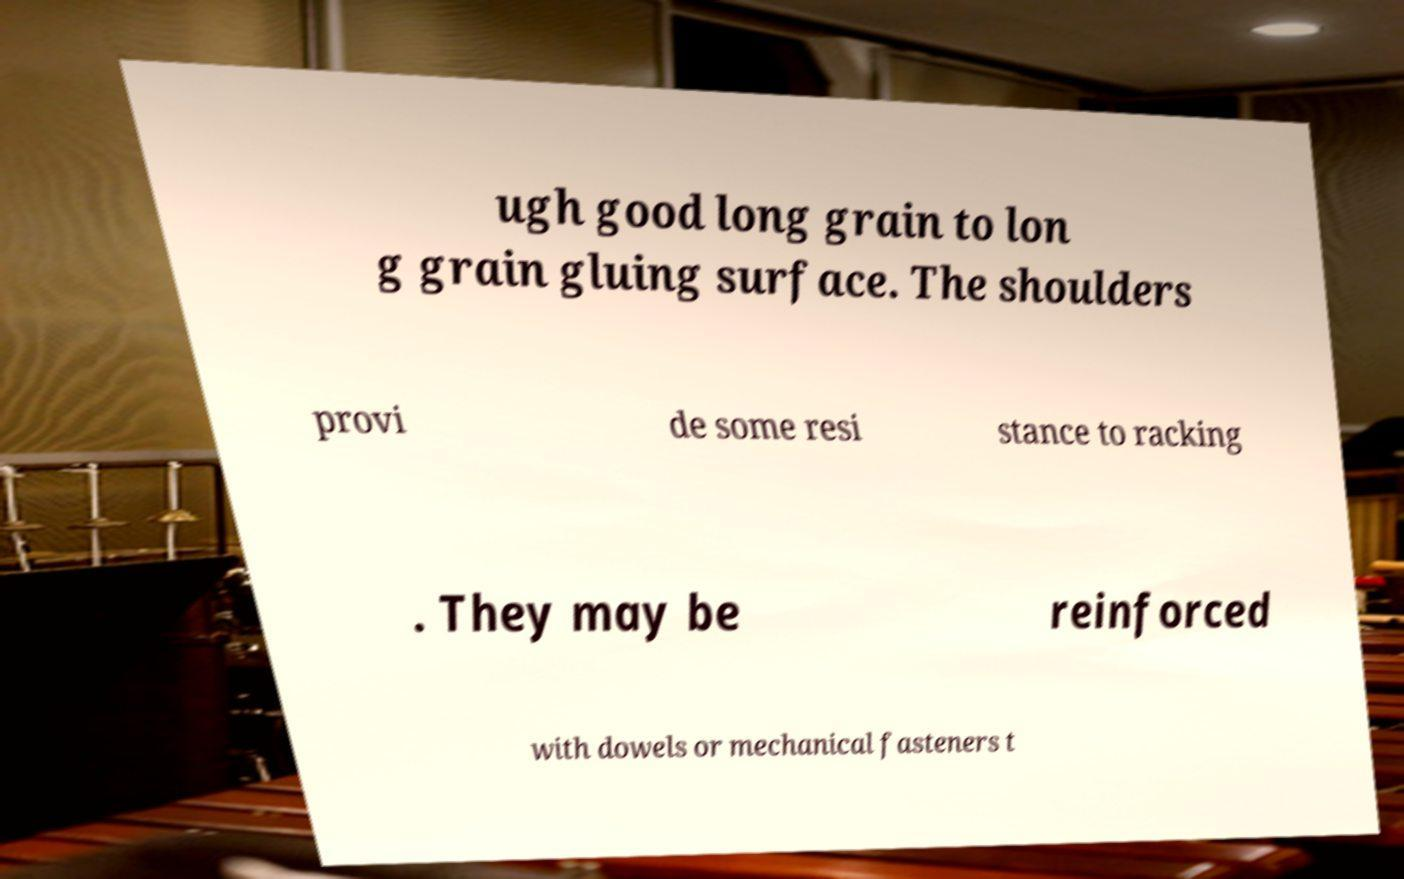For documentation purposes, I need the text within this image transcribed. Could you provide that? ugh good long grain to lon g grain gluing surface. The shoulders provi de some resi stance to racking . They may be reinforced with dowels or mechanical fasteners t 